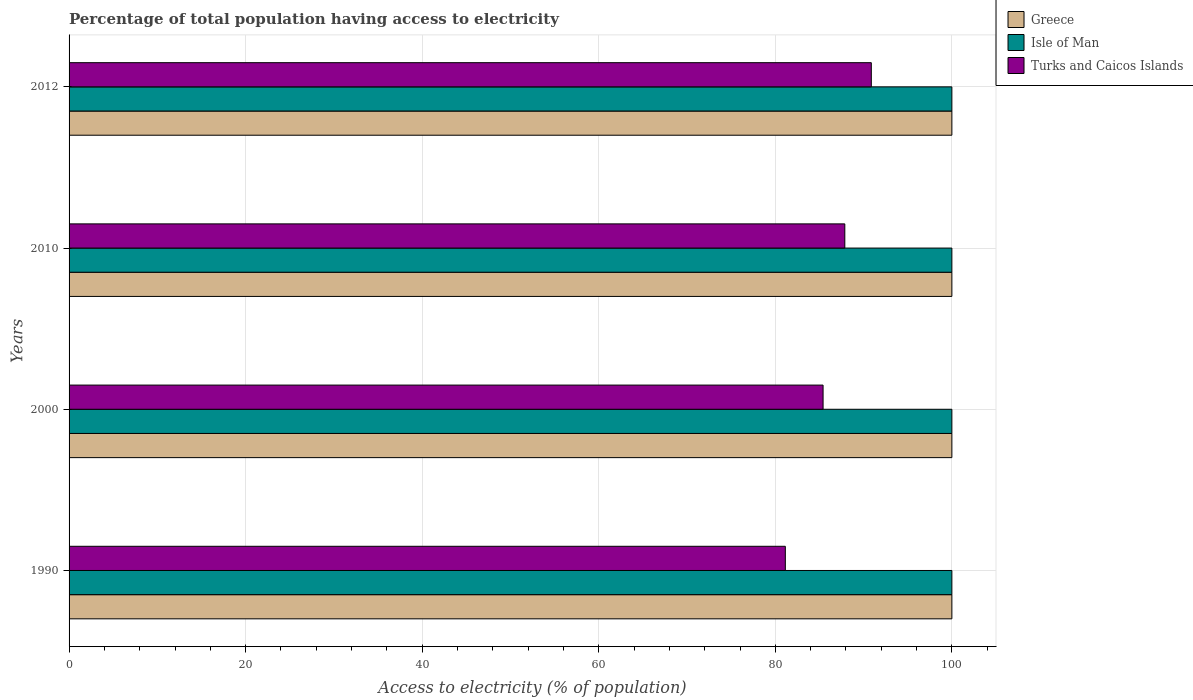Are the number of bars per tick equal to the number of legend labels?
Offer a very short reply. Yes. How many bars are there on the 4th tick from the top?
Your answer should be compact. 3. How many bars are there on the 2nd tick from the bottom?
Provide a succinct answer. 3. In how many cases, is the number of bars for a given year not equal to the number of legend labels?
Your answer should be very brief. 0. What is the percentage of population that have access to electricity in Greece in 1990?
Your answer should be compact. 100. Across all years, what is the maximum percentage of population that have access to electricity in Greece?
Keep it short and to the point. 100. Across all years, what is the minimum percentage of population that have access to electricity in Turks and Caicos Islands?
Make the answer very short. 81.14. In which year was the percentage of population that have access to electricity in Isle of Man minimum?
Provide a succinct answer. 1990. What is the total percentage of population that have access to electricity in Greece in the graph?
Your response must be concise. 400. What is the difference between the percentage of population that have access to electricity in Turks and Caicos Islands in 1990 and that in 2012?
Your answer should be compact. -9.74. What is the difference between the percentage of population that have access to electricity in Isle of Man in 2010 and the percentage of population that have access to electricity in Turks and Caicos Islands in 2012?
Your answer should be very brief. 9.12. What is the average percentage of population that have access to electricity in Greece per year?
Your response must be concise. 100. In the year 2012, what is the difference between the percentage of population that have access to electricity in Isle of Man and percentage of population that have access to electricity in Greece?
Your response must be concise. 0. In how many years, is the percentage of population that have access to electricity in Greece greater than 12 %?
Provide a short and direct response. 4. Is the difference between the percentage of population that have access to electricity in Isle of Man in 2010 and 2012 greater than the difference between the percentage of population that have access to electricity in Greece in 2010 and 2012?
Provide a succinct answer. No. What is the difference between the highest and the second highest percentage of population that have access to electricity in Turks and Caicos Islands?
Give a very brief answer. 3. What is the difference between the highest and the lowest percentage of population that have access to electricity in Greece?
Give a very brief answer. 0. What does the 2nd bar from the top in 2010 represents?
Ensure brevity in your answer.  Isle of Man. How many years are there in the graph?
Ensure brevity in your answer.  4. Are the values on the major ticks of X-axis written in scientific E-notation?
Your answer should be very brief. No. Does the graph contain any zero values?
Your answer should be very brief. No. How many legend labels are there?
Provide a short and direct response. 3. What is the title of the graph?
Your answer should be very brief. Percentage of total population having access to electricity. Does "Finland" appear as one of the legend labels in the graph?
Keep it short and to the point. No. What is the label or title of the X-axis?
Make the answer very short. Access to electricity (% of population). What is the label or title of the Y-axis?
Your answer should be very brief. Years. What is the Access to electricity (% of population) of Greece in 1990?
Provide a succinct answer. 100. What is the Access to electricity (% of population) of Isle of Man in 1990?
Keep it short and to the point. 100. What is the Access to electricity (% of population) in Turks and Caicos Islands in 1990?
Your response must be concise. 81.14. What is the Access to electricity (% of population) of Greece in 2000?
Offer a very short reply. 100. What is the Access to electricity (% of population) of Turks and Caicos Islands in 2000?
Offer a very short reply. 85.41. What is the Access to electricity (% of population) in Turks and Caicos Islands in 2010?
Provide a succinct answer. 87.87. What is the Access to electricity (% of population) of Isle of Man in 2012?
Your answer should be compact. 100. What is the Access to electricity (% of population) in Turks and Caicos Islands in 2012?
Provide a short and direct response. 90.88. Across all years, what is the maximum Access to electricity (% of population) of Turks and Caicos Islands?
Offer a very short reply. 90.88. Across all years, what is the minimum Access to electricity (% of population) in Greece?
Your answer should be very brief. 100. Across all years, what is the minimum Access to electricity (% of population) of Turks and Caicos Islands?
Offer a terse response. 81.14. What is the total Access to electricity (% of population) in Greece in the graph?
Ensure brevity in your answer.  400. What is the total Access to electricity (% of population) of Turks and Caicos Islands in the graph?
Your response must be concise. 345.3. What is the difference between the Access to electricity (% of population) in Greece in 1990 and that in 2000?
Provide a short and direct response. 0. What is the difference between the Access to electricity (% of population) in Turks and Caicos Islands in 1990 and that in 2000?
Give a very brief answer. -4.28. What is the difference between the Access to electricity (% of population) in Greece in 1990 and that in 2010?
Keep it short and to the point. 0. What is the difference between the Access to electricity (% of population) in Turks and Caicos Islands in 1990 and that in 2010?
Provide a succinct answer. -6.74. What is the difference between the Access to electricity (% of population) in Turks and Caicos Islands in 1990 and that in 2012?
Give a very brief answer. -9.74. What is the difference between the Access to electricity (% of population) in Greece in 2000 and that in 2010?
Provide a succinct answer. 0. What is the difference between the Access to electricity (% of population) in Isle of Man in 2000 and that in 2010?
Your response must be concise. 0. What is the difference between the Access to electricity (% of population) in Turks and Caicos Islands in 2000 and that in 2010?
Offer a very short reply. -2.46. What is the difference between the Access to electricity (% of population) of Turks and Caicos Islands in 2000 and that in 2012?
Your response must be concise. -5.46. What is the difference between the Access to electricity (% of population) in Isle of Man in 2010 and that in 2012?
Offer a very short reply. 0. What is the difference between the Access to electricity (% of population) of Turks and Caicos Islands in 2010 and that in 2012?
Keep it short and to the point. -3. What is the difference between the Access to electricity (% of population) in Greece in 1990 and the Access to electricity (% of population) in Turks and Caicos Islands in 2000?
Provide a short and direct response. 14.59. What is the difference between the Access to electricity (% of population) in Isle of Man in 1990 and the Access to electricity (% of population) in Turks and Caicos Islands in 2000?
Keep it short and to the point. 14.59. What is the difference between the Access to electricity (% of population) of Greece in 1990 and the Access to electricity (% of population) of Isle of Man in 2010?
Your response must be concise. 0. What is the difference between the Access to electricity (% of population) in Greece in 1990 and the Access to electricity (% of population) in Turks and Caicos Islands in 2010?
Offer a very short reply. 12.13. What is the difference between the Access to electricity (% of population) in Isle of Man in 1990 and the Access to electricity (% of population) in Turks and Caicos Islands in 2010?
Your response must be concise. 12.13. What is the difference between the Access to electricity (% of population) in Greece in 1990 and the Access to electricity (% of population) in Turks and Caicos Islands in 2012?
Give a very brief answer. 9.12. What is the difference between the Access to electricity (% of population) of Isle of Man in 1990 and the Access to electricity (% of population) of Turks and Caicos Islands in 2012?
Provide a short and direct response. 9.12. What is the difference between the Access to electricity (% of population) in Greece in 2000 and the Access to electricity (% of population) in Isle of Man in 2010?
Provide a short and direct response. 0. What is the difference between the Access to electricity (% of population) of Greece in 2000 and the Access to electricity (% of population) of Turks and Caicos Islands in 2010?
Your answer should be compact. 12.13. What is the difference between the Access to electricity (% of population) of Isle of Man in 2000 and the Access to electricity (% of population) of Turks and Caicos Islands in 2010?
Provide a succinct answer. 12.13. What is the difference between the Access to electricity (% of population) in Greece in 2000 and the Access to electricity (% of population) in Turks and Caicos Islands in 2012?
Your answer should be compact. 9.12. What is the difference between the Access to electricity (% of population) of Isle of Man in 2000 and the Access to electricity (% of population) of Turks and Caicos Islands in 2012?
Your response must be concise. 9.12. What is the difference between the Access to electricity (% of population) in Greece in 2010 and the Access to electricity (% of population) in Isle of Man in 2012?
Your answer should be very brief. 0. What is the difference between the Access to electricity (% of population) in Greece in 2010 and the Access to electricity (% of population) in Turks and Caicos Islands in 2012?
Offer a very short reply. 9.12. What is the difference between the Access to electricity (% of population) of Isle of Man in 2010 and the Access to electricity (% of population) of Turks and Caicos Islands in 2012?
Give a very brief answer. 9.12. What is the average Access to electricity (% of population) of Greece per year?
Your response must be concise. 100. What is the average Access to electricity (% of population) of Isle of Man per year?
Your answer should be very brief. 100. What is the average Access to electricity (% of population) of Turks and Caicos Islands per year?
Keep it short and to the point. 86.32. In the year 1990, what is the difference between the Access to electricity (% of population) of Greece and Access to electricity (% of population) of Isle of Man?
Offer a terse response. 0. In the year 1990, what is the difference between the Access to electricity (% of population) of Greece and Access to electricity (% of population) of Turks and Caicos Islands?
Your response must be concise. 18.86. In the year 1990, what is the difference between the Access to electricity (% of population) in Isle of Man and Access to electricity (% of population) in Turks and Caicos Islands?
Your answer should be very brief. 18.86. In the year 2000, what is the difference between the Access to electricity (% of population) of Greece and Access to electricity (% of population) of Turks and Caicos Islands?
Your answer should be compact. 14.59. In the year 2000, what is the difference between the Access to electricity (% of population) of Isle of Man and Access to electricity (% of population) of Turks and Caicos Islands?
Provide a succinct answer. 14.59. In the year 2010, what is the difference between the Access to electricity (% of population) in Greece and Access to electricity (% of population) in Isle of Man?
Your response must be concise. 0. In the year 2010, what is the difference between the Access to electricity (% of population) of Greece and Access to electricity (% of population) of Turks and Caicos Islands?
Your answer should be very brief. 12.13. In the year 2010, what is the difference between the Access to electricity (% of population) of Isle of Man and Access to electricity (% of population) of Turks and Caicos Islands?
Give a very brief answer. 12.13. In the year 2012, what is the difference between the Access to electricity (% of population) of Greece and Access to electricity (% of population) of Turks and Caicos Islands?
Your answer should be very brief. 9.12. In the year 2012, what is the difference between the Access to electricity (% of population) in Isle of Man and Access to electricity (% of population) in Turks and Caicos Islands?
Provide a short and direct response. 9.12. What is the ratio of the Access to electricity (% of population) in Greece in 1990 to that in 2000?
Your answer should be very brief. 1. What is the ratio of the Access to electricity (% of population) of Isle of Man in 1990 to that in 2000?
Give a very brief answer. 1. What is the ratio of the Access to electricity (% of population) of Turks and Caicos Islands in 1990 to that in 2000?
Your answer should be very brief. 0.95. What is the ratio of the Access to electricity (% of population) of Isle of Man in 1990 to that in 2010?
Provide a succinct answer. 1. What is the ratio of the Access to electricity (% of population) of Turks and Caicos Islands in 1990 to that in 2010?
Make the answer very short. 0.92. What is the ratio of the Access to electricity (% of population) in Greece in 1990 to that in 2012?
Make the answer very short. 1. What is the ratio of the Access to electricity (% of population) in Isle of Man in 1990 to that in 2012?
Offer a terse response. 1. What is the ratio of the Access to electricity (% of population) in Turks and Caicos Islands in 1990 to that in 2012?
Offer a terse response. 0.89. What is the ratio of the Access to electricity (% of population) in Greece in 2000 to that in 2010?
Offer a very short reply. 1. What is the ratio of the Access to electricity (% of population) of Isle of Man in 2000 to that in 2010?
Ensure brevity in your answer.  1. What is the ratio of the Access to electricity (% of population) of Turks and Caicos Islands in 2000 to that in 2010?
Ensure brevity in your answer.  0.97. What is the ratio of the Access to electricity (% of population) of Greece in 2000 to that in 2012?
Your response must be concise. 1. What is the ratio of the Access to electricity (% of population) in Turks and Caicos Islands in 2000 to that in 2012?
Your answer should be very brief. 0.94. What is the ratio of the Access to electricity (% of population) in Isle of Man in 2010 to that in 2012?
Your response must be concise. 1. What is the difference between the highest and the second highest Access to electricity (% of population) in Turks and Caicos Islands?
Your answer should be very brief. 3. What is the difference between the highest and the lowest Access to electricity (% of population) in Isle of Man?
Offer a very short reply. 0. What is the difference between the highest and the lowest Access to electricity (% of population) in Turks and Caicos Islands?
Offer a very short reply. 9.74. 